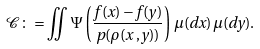<formula> <loc_0><loc_0><loc_500><loc_500>\mathcal { C } \colon = \iint \Psi \left ( \frac { f ( x ) - f ( y ) } { p ( \rho ( x \, , y ) ) } \right ) \, \mu ( d x ) \, \mu ( d y ) .</formula> 